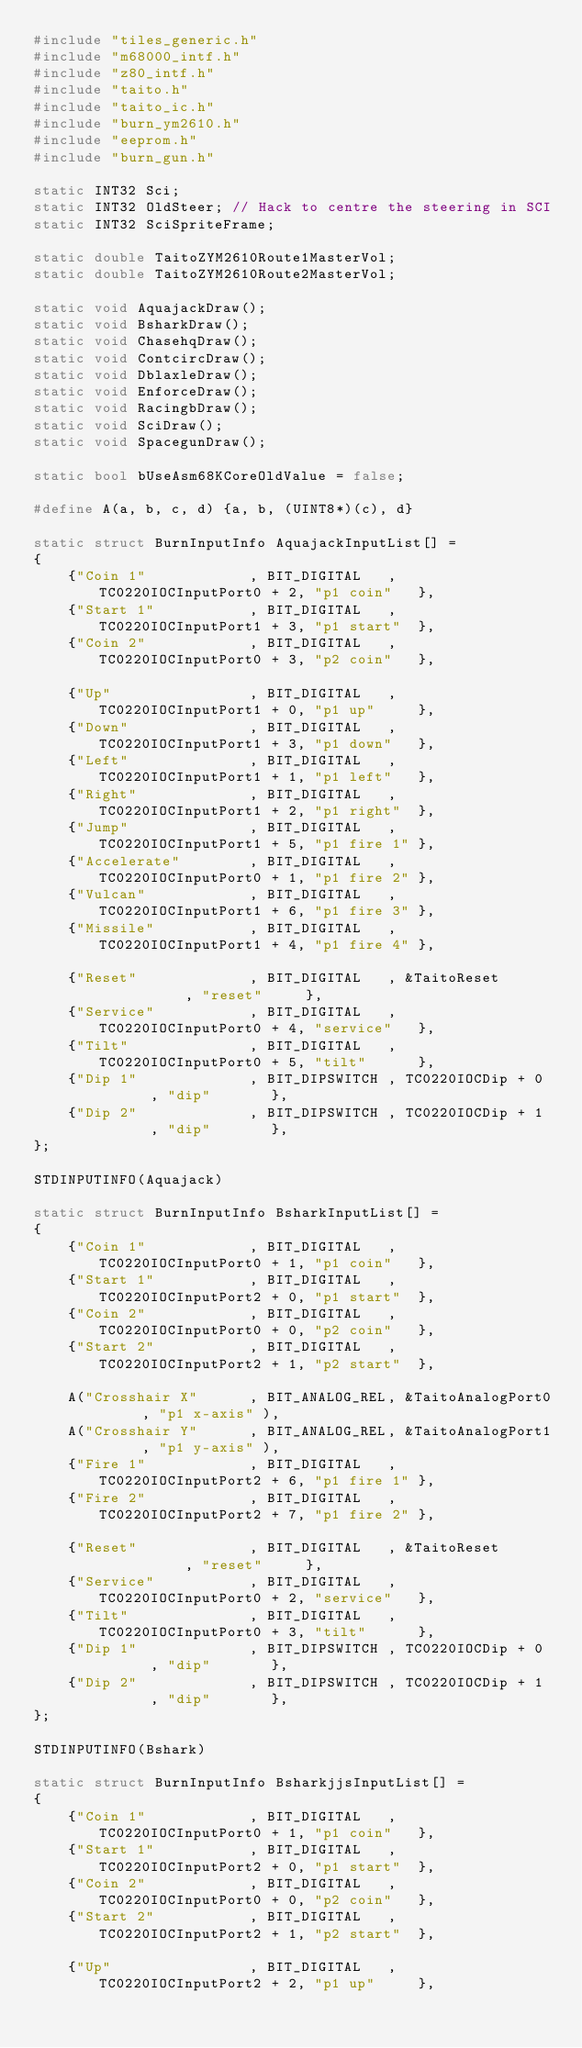<code> <loc_0><loc_0><loc_500><loc_500><_C++_>#include "tiles_generic.h"
#include "m68000_intf.h"
#include "z80_intf.h"
#include "taito.h"
#include "taito_ic.h"
#include "burn_ym2610.h"
#include "eeprom.h"
#include "burn_gun.h"

static INT32 Sci;
static INT32 OldSteer; // Hack to centre the steering in SCI
static INT32 SciSpriteFrame;

static double TaitoZYM2610Route1MasterVol;
static double TaitoZYM2610Route2MasterVol;

static void AquajackDraw();
static void BsharkDraw();
static void ChasehqDraw();
static void ContcircDraw();
static void DblaxleDraw();
static void EnforceDraw();
static void RacingbDraw();
static void SciDraw();
static void SpacegunDraw();

static bool bUseAsm68KCoreOldValue = false;

#define A(a, b, c, d) {a, b, (UINT8*)(c), d}

static struct BurnInputInfo AquajackInputList[] =
{
	{"Coin 1"            , BIT_DIGITAL   , TC0220IOCInputPort0 + 2, "p1 coin"   },
	{"Start 1"           , BIT_DIGITAL   , TC0220IOCInputPort1 + 3, "p1 start"  },
	{"Coin 2"            , BIT_DIGITAL   , TC0220IOCInputPort0 + 3, "p2 coin"   },

	{"Up"                , BIT_DIGITAL   , TC0220IOCInputPort1 + 0, "p1 up"     },
	{"Down"              , BIT_DIGITAL   , TC0220IOCInputPort1 + 3, "p1 down"   },
	{"Left"              , BIT_DIGITAL   , TC0220IOCInputPort1 + 1, "p1 left"   },
	{"Right"             , BIT_DIGITAL   , TC0220IOCInputPort1 + 2, "p1 right"  },
	{"Jump"              , BIT_DIGITAL   , TC0220IOCInputPort1 + 5, "p1 fire 1" },
	{"Accelerate"        , BIT_DIGITAL   , TC0220IOCInputPort0 + 1, "p1 fire 2" },
	{"Vulcan"            , BIT_DIGITAL   , TC0220IOCInputPort1 + 6, "p1 fire 3" },
	{"Missile"           , BIT_DIGITAL   , TC0220IOCInputPort1 + 4, "p1 fire 4" },
	
	{"Reset"             , BIT_DIGITAL   , &TaitoReset           , "reset"     },
	{"Service"           , BIT_DIGITAL   , TC0220IOCInputPort0 + 4, "service"   },
	{"Tilt"              , BIT_DIGITAL   , TC0220IOCInputPort0 + 5, "tilt"      },
	{"Dip 1"             , BIT_DIPSWITCH , TC0220IOCDip + 0       , "dip"       },
	{"Dip 2"             , BIT_DIPSWITCH , TC0220IOCDip + 1       , "dip"       },
};

STDINPUTINFO(Aquajack)

static struct BurnInputInfo BsharkInputList[] =
{
	{"Coin 1"            , BIT_DIGITAL   , TC0220IOCInputPort0 + 1, "p1 coin"   },
	{"Start 1"           , BIT_DIGITAL   , TC0220IOCInputPort2 + 0, "p1 start"  },
	{"Coin 2"            , BIT_DIGITAL   , TC0220IOCInputPort0 + 0, "p2 coin"   },
	{"Start 2"           , BIT_DIGITAL   , TC0220IOCInputPort2 + 1, "p2 start"  },

	A("Crosshair X"      , BIT_ANALOG_REL, &TaitoAnalogPort0     , "p1 x-axis" ),
	A("Crosshair Y"      , BIT_ANALOG_REL, &TaitoAnalogPort1     , "p1 y-axis" ),
	{"Fire 1"            , BIT_DIGITAL   , TC0220IOCInputPort2 + 6, "p1 fire 1" },
	{"Fire 2"            , BIT_DIGITAL   , TC0220IOCInputPort2 + 7, "p1 fire 2" },
	
	{"Reset"             , BIT_DIGITAL   , &TaitoReset           , "reset"     },
	{"Service"           , BIT_DIGITAL   , TC0220IOCInputPort0 + 2, "service"   },
	{"Tilt"              , BIT_DIGITAL   , TC0220IOCInputPort0 + 3, "tilt"      },
	{"Dip 1"             , BIT_DIPSWITCH , TC0220IOCDip + 0       , "dip"       },
	{"Dip 2"             , BIT_DIPSWITCH , TC0220IOCDip + 1       , "dip"       },
};

STDINPUTINFO(Bshark)

static struct BurnInputInfo BsharkjjsInputList[] =
{
	{"Coin 1"            , BIT_DIGITAL   , TC0220IOCInputPort0 + 1, "p1 coin"   },
	{"Start 1"           , BIT_DIGITAL   , TC0220IOCInputPort2 + 0, "p1 start"  },
	{"Coin 2"            , BIT_DIGITAL   , TC0220IOCInputPort0 + 0, "p2 coin"   },
	{"Start 2"           , BIT_DIGITAL   , TC0220IOCInputPort2 + 1, "p2 start"  },

	{"Up"                , BIT_DIGITAL   , TC0220IOCInputPort2 + 2, "p1 up"     },</code> 